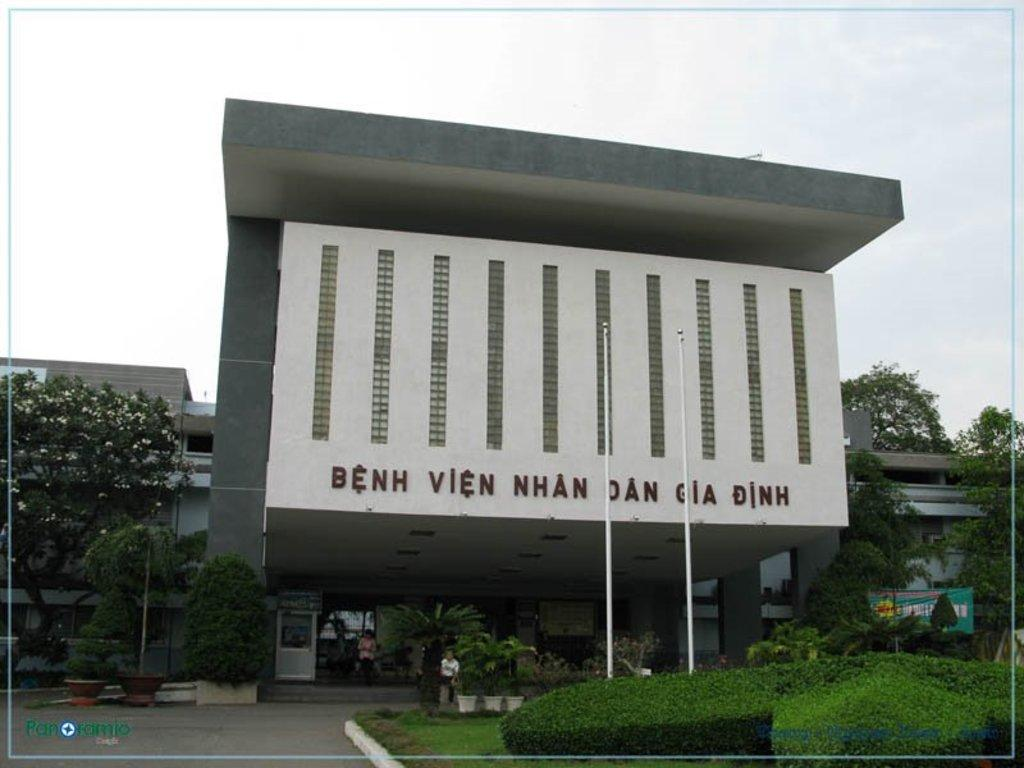What types of vegetation are present at the bottom of the image? There are plants and trees at the bottom of the image. What structures can be seen in the middle of the image? There are buildings in the middle of the image. What part of the natural environment is visible in the image? The sky is visible in the background of the image. What type of book is being used to lock the door in the image? There is no book or door present in the image; it features plants, trees, buildings, and the sky. 